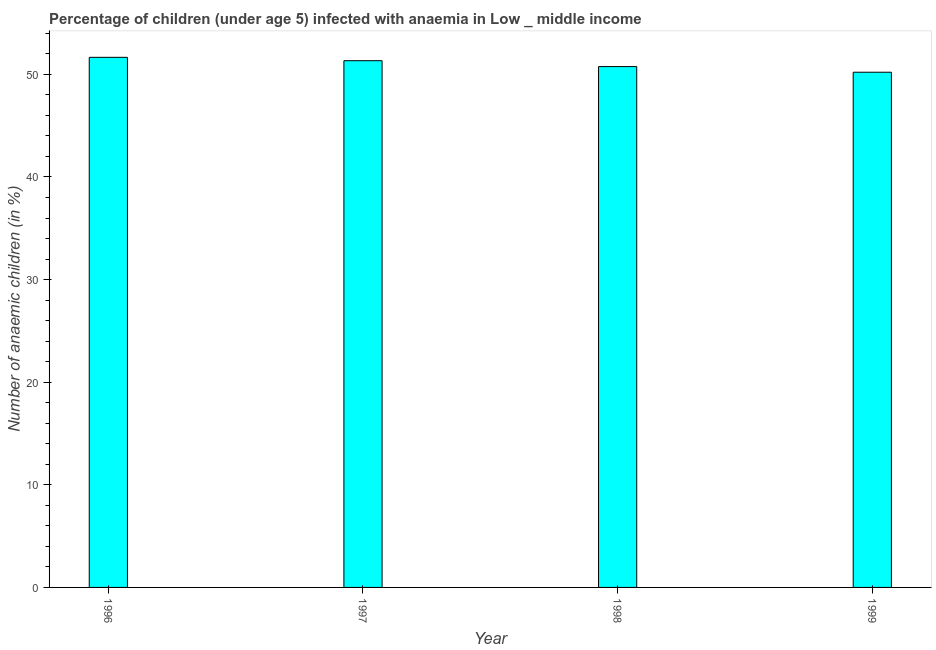Does the graph contain any zero values?
Give a very brief answer. No. Does the graph contain grids?
Your response must be concise. No. What is the title of the graph?
Your answer should be compact. Percentage of children (under age 5) infected with anaemia in Low _ middle income. What is the label or title of the X-axis?
Your response must be concise. Year. What is the label or title of the Y-axis?
Provide a short and direct response. Number of anaemic children (in %). What is the number of anaemic children in 1999?
Your answer should be compact. 50.21. Across all years, what is the maximum number of anaemic children?
Your response must be concise. 51.66. Across all years, what is the minimum number of anaemic children?
Your answer should be compact. 50.21. In which year was the number of anaemic children maximum?
Give a very brief answer. 1996. What is the sum of the number of anaemic children?
Provide a short and direct response. 203.96. What is the difference between the number of anaemic children in 1997 and 1999?
Offer a terse response. 1.12. What is the average number of anaemic children per year?
Keep it short and to the point. 50.99. What is the median number of anaemic children?
Your answer should be compact. 51.05. Do a majority of the years between 1997 and 1996 (inclusive) have number of anaemic children greater than 30 %?
Make the answer very short. No. What is the ratio of the number of anaemic children in 1996 to that in 1999?
Make the answer very short. 1.03. What is the difference between the highest and the second highest number of anaemic children?
Your response must be concise. 0.33. Is the sum of the number of anaemic children in 1996 and 1997 greater than the maximum number of anaemic children across all years?
Your answer should be very brief. Yes. What is the difference between the highest and the lowest number of anaemic children?
Your answer should be compact. 1.45. What is the difference between two consecutive major ticks on the Y-axis?
Ensure brevity in your answer.  10. What is the Number of anaemic children (in %) in 1996?
Offer a terse response. 51.66. What is the Number of anaemic children (in %) in 1997?
Your response must be concise. 51.33. What is the Number of anaemic children (in %) in 1998?
Offer a very short reply. 50.76. What is the Number of anaemic children (in %) of 1999?
Give a very brief answer. 50.21. What is the difference between the Number of anaemic children (in %) in 1996 and 1997?
Offer a very short reply. 0.33. What is the difference between the Number of anaemic children (in %) in 1996 and 1998?
Provide a short and direct response. 0.9. What is the difference between the Number of anaemic children (in %) in 1996 and 1999?
Your answer should be very brief. 1.45. What is the difference between the Number of anaemic children (in %) in 1997 and 1998?
Give a very brief answer. 0.57. What is the difference between the Number of anaemic children (in %) in 1997 and 1999?
Provide a succinct answer. 1.12. What is the difference between the Number of anaemic children (in %) in 1998 and 1999?
Your answer should be compact. 0.55. What is the ratio of the Number of anaemic children (in %) in 1996 to that in 1997?
Make the answer very short. 1.01. What is the ratio of the Number of anaemic children (in %) in 1997 to that in 1999?
Your response must be concise. 1.02. 